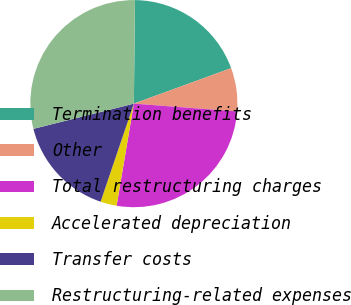Convert chart to OTSL. <chart><loc_0><loc_0><loc_500><loc_500><pie_chart><fcel>Termination benefits<fcel>Other<fcel>Total restructuring charges<fcel>Accelerated depreciation<fcel>Transfer costs<fcel>Restructuring-related expenses<nl><fcel>19.26%<fcel>6.77%<fcel>26.46%<fcel>2.54%<fcel>15.88%<fcel>29.09%<nl></chart> 